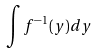<formula> <loc_0><loc_0><loc_500><loc_500>\int f ^ { - 1 } ( y ) d y</formula> 